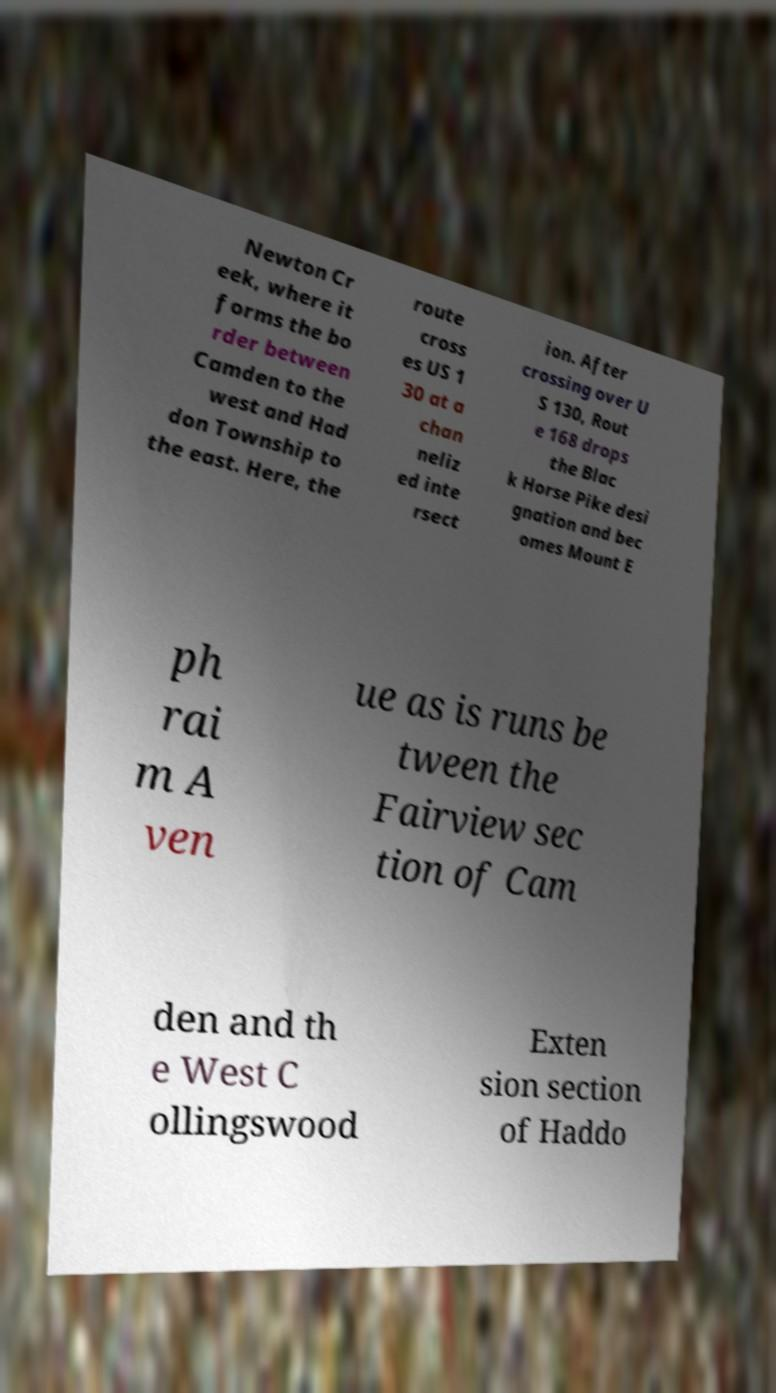Could you assist in decoding the text presented in this image and type it out clearly? Newton Cr eek, where it forms the bo rder between Camden to the west and Had don Township to the east. Here, the route cross es US 1 30 at a chan neliz ed inte rsect ion. After crossing over U S 130, Rout e 168 drops the Blac k Horse Pike desi gnation and bec omes Mount E ph rai m A ven ue as is runs be tween the Fairview sec tion of Cam den and th e West C ollingswood Exten sion section of Haddo 